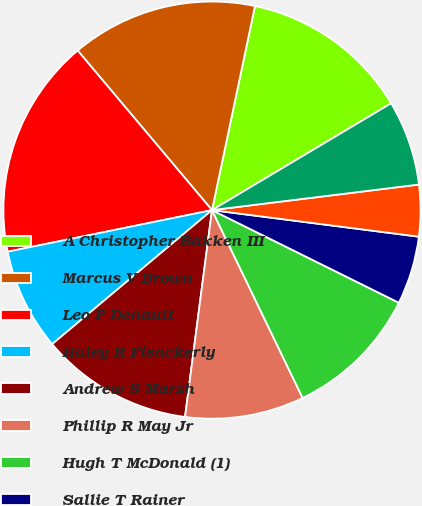<chart> <loc_0><loc_0><loc_500><loc_500><pie_chart><fcel>A Christopher Bakken III<fcel>Marcus V Brown<fcel>Leo P Denault<fcel>Haley R Fisackerly<fcel>Andrew S Marsh<fcel>Phillip R May Jr<fcel>Hugh T McDonald (1)<fcel>Sallie T Rainer<fcel>Charles L Rice Jr<fcel>Richard C Riley<nl><fcel>13.14%<fcel>14.44%<fcel>17.06%<fcel>7.91%<fcel>11.83%<fcel>9.22%<fcel>10.52%<fcel>5.29%<fcel>3.99%<fcel>6.6%<nl></chart> 